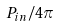Convert formula to latex. <formula><loc_0><loc_0><loc_500><loc_500>P _ { i n } / 4 \pi</formula> 